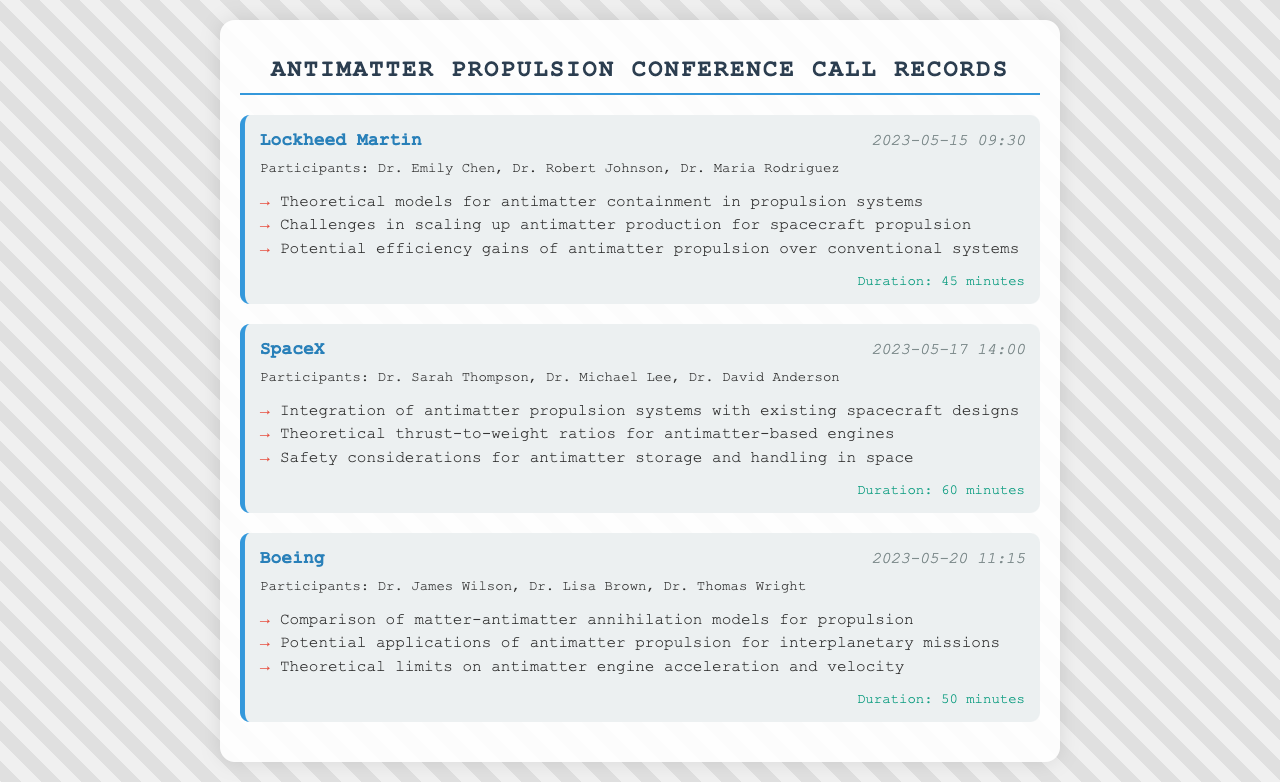What was the date of the call with Lockheed Martin? The date of the call is provided in the document, which states "2023-05-15".
Answer: 2023-05-15 Who participated in the SpaceX call? The document lists the names of participants involved in the SpaceX call, which are Dr. Sarah Thompson, Dr. Michael Lee, and Dr. David Anderson.
Answer: Dr. Sarah Thompson, Dr. Michael Lee, Dr. David Anderson How long did the Boeing conference call last? The duration of the Boeing call is clearly stated in the document as "50 minutes".
Answer: 50 minutes What is one challenge discussed in the Lockheed Martin call? One of the challenges mentioned during the Lockheed Martin discussion is "Challenges in scaling up antimatter production for spacecraft propulsion".
Answer: Challenges in scaling up antimatter production for spacecraft propulsion How many theoretical models were discussed in the Lockheed Martin call? The document lists the topics discussed, including theoretical models, which are three in total.
Answer: Three Which company had a call about safety considerations for antimatter? The document indicates that the company SpaceX discussed safety considerations regarding antimatter storage and handling.
Answer: SpaceX What is one potential application of antimatter propulsion mentioned by Boeing? The document highlights "Potential applications of antimatter propulsion for interplanetary missions" as one mentioned application.
Answer: Potential applications of antimatter propulsion for interplanetary missions What are the two primary focuses of the SpaceX call? The document outlines two key topics: "Integration of antimatter propulsion systems with existing spacecraft designs" and "Theoretical thrust-to-weight ratios for antimatter-based engines".
Answer: Integration of antimatter propulsion systems with existing spacecraft designs, Theoretical thrust-to-weight ratios for antimatter-based engines How many participants were in the Lockheed Martin call? The document specifies the number of participants in the Lockheed Martin call as three, including Dr. Emily Chen, Dr. Robert Johnson, and Dr. Maria Rodriguez.
Answer: Three 